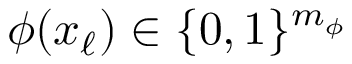Convert formula to latex. <formula><loc_0><loc_0><loc_500><loc_500>\phi ( x _ { \ell } ) \in \{ 0 , 1 \} ^ { m _ { \phi } }</formula> 